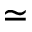Convert formula to latex. <formula><loc_0><loc_0><loc_500><loc_500>\simeq</formula> 